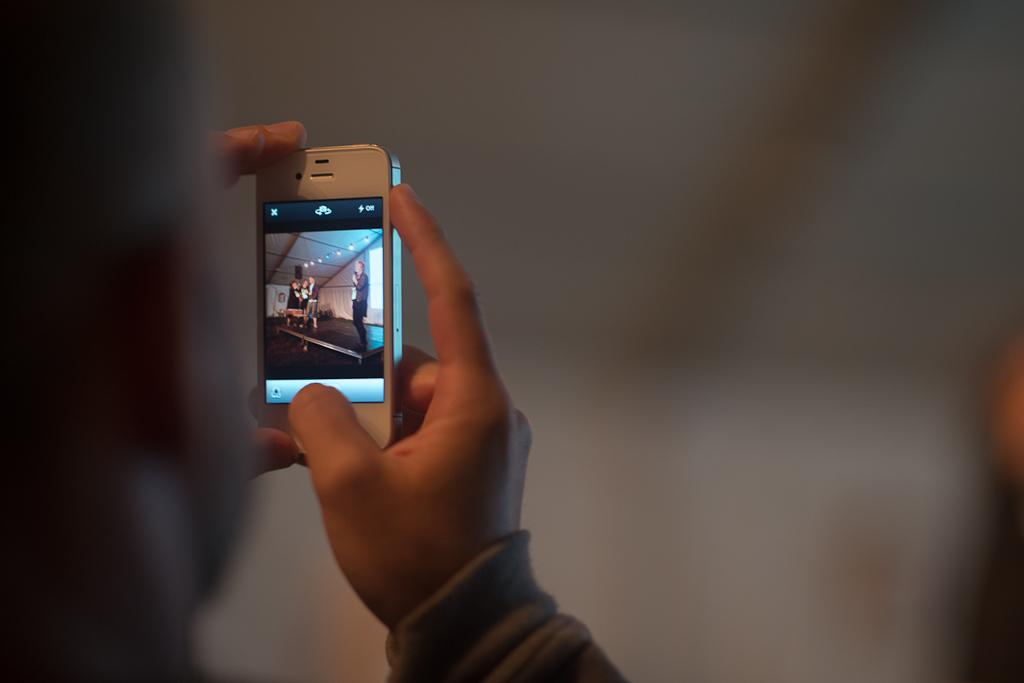What is the main subject of the image? There is a person in the image. What is the person holding in his hand? The person is holding a mobile phone in his hand. What type of prison can be seen in the background of the image? There is no prison present in the image; it only features a person holding a mobile phone. 